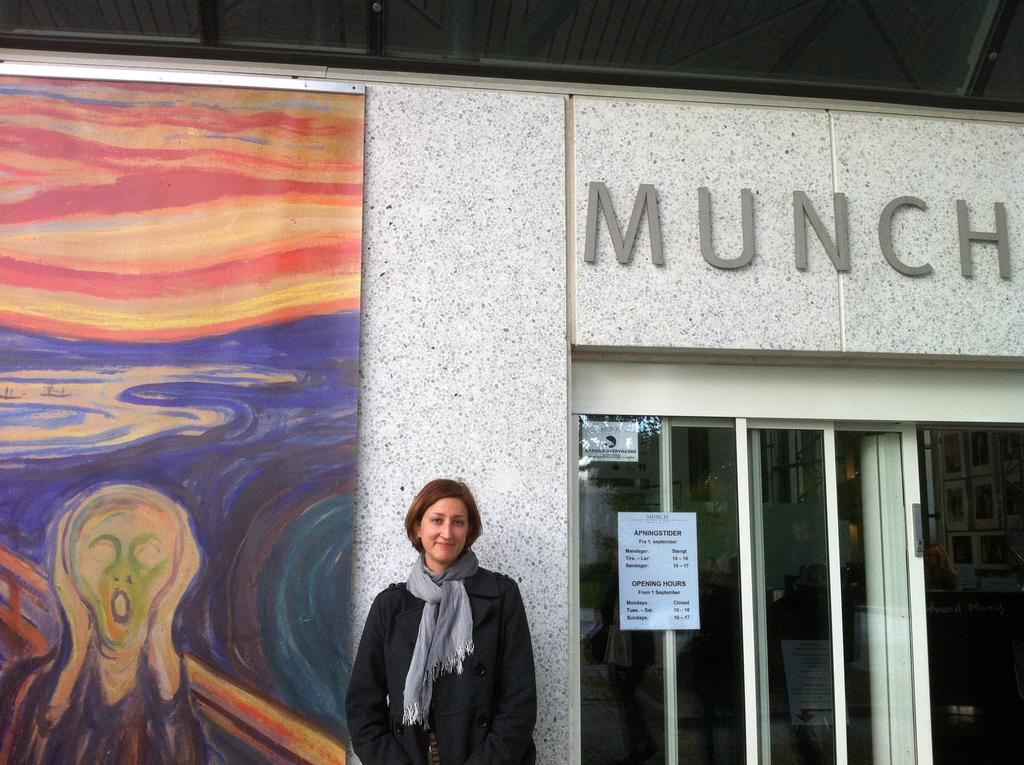How would you summarize this image in a sentence or two? In this image in the center there is one woman standing and smiling, and in the background there is a board. On the board there is painting and on the right side there are glass doors, on the doors there are some posters and wall. On the wall there is some text, at the top there is ceiling. 